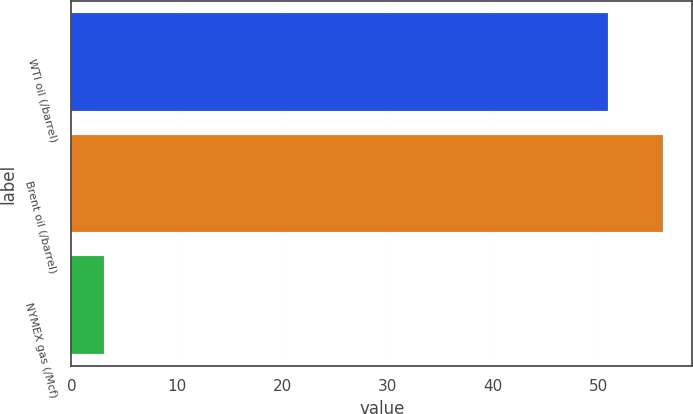Convert chart to OTSL. <chart><loc_0><loc_0><loc_500><loc_500><bar_chart><fcel>WTI oil (/barrel)<fcel>Brent oil (/barrel)<fcel>NYMEX gas (/Mcf)<nl><fcel>50.95<fcel>56.12<fcel>3.09<nl></chart> 